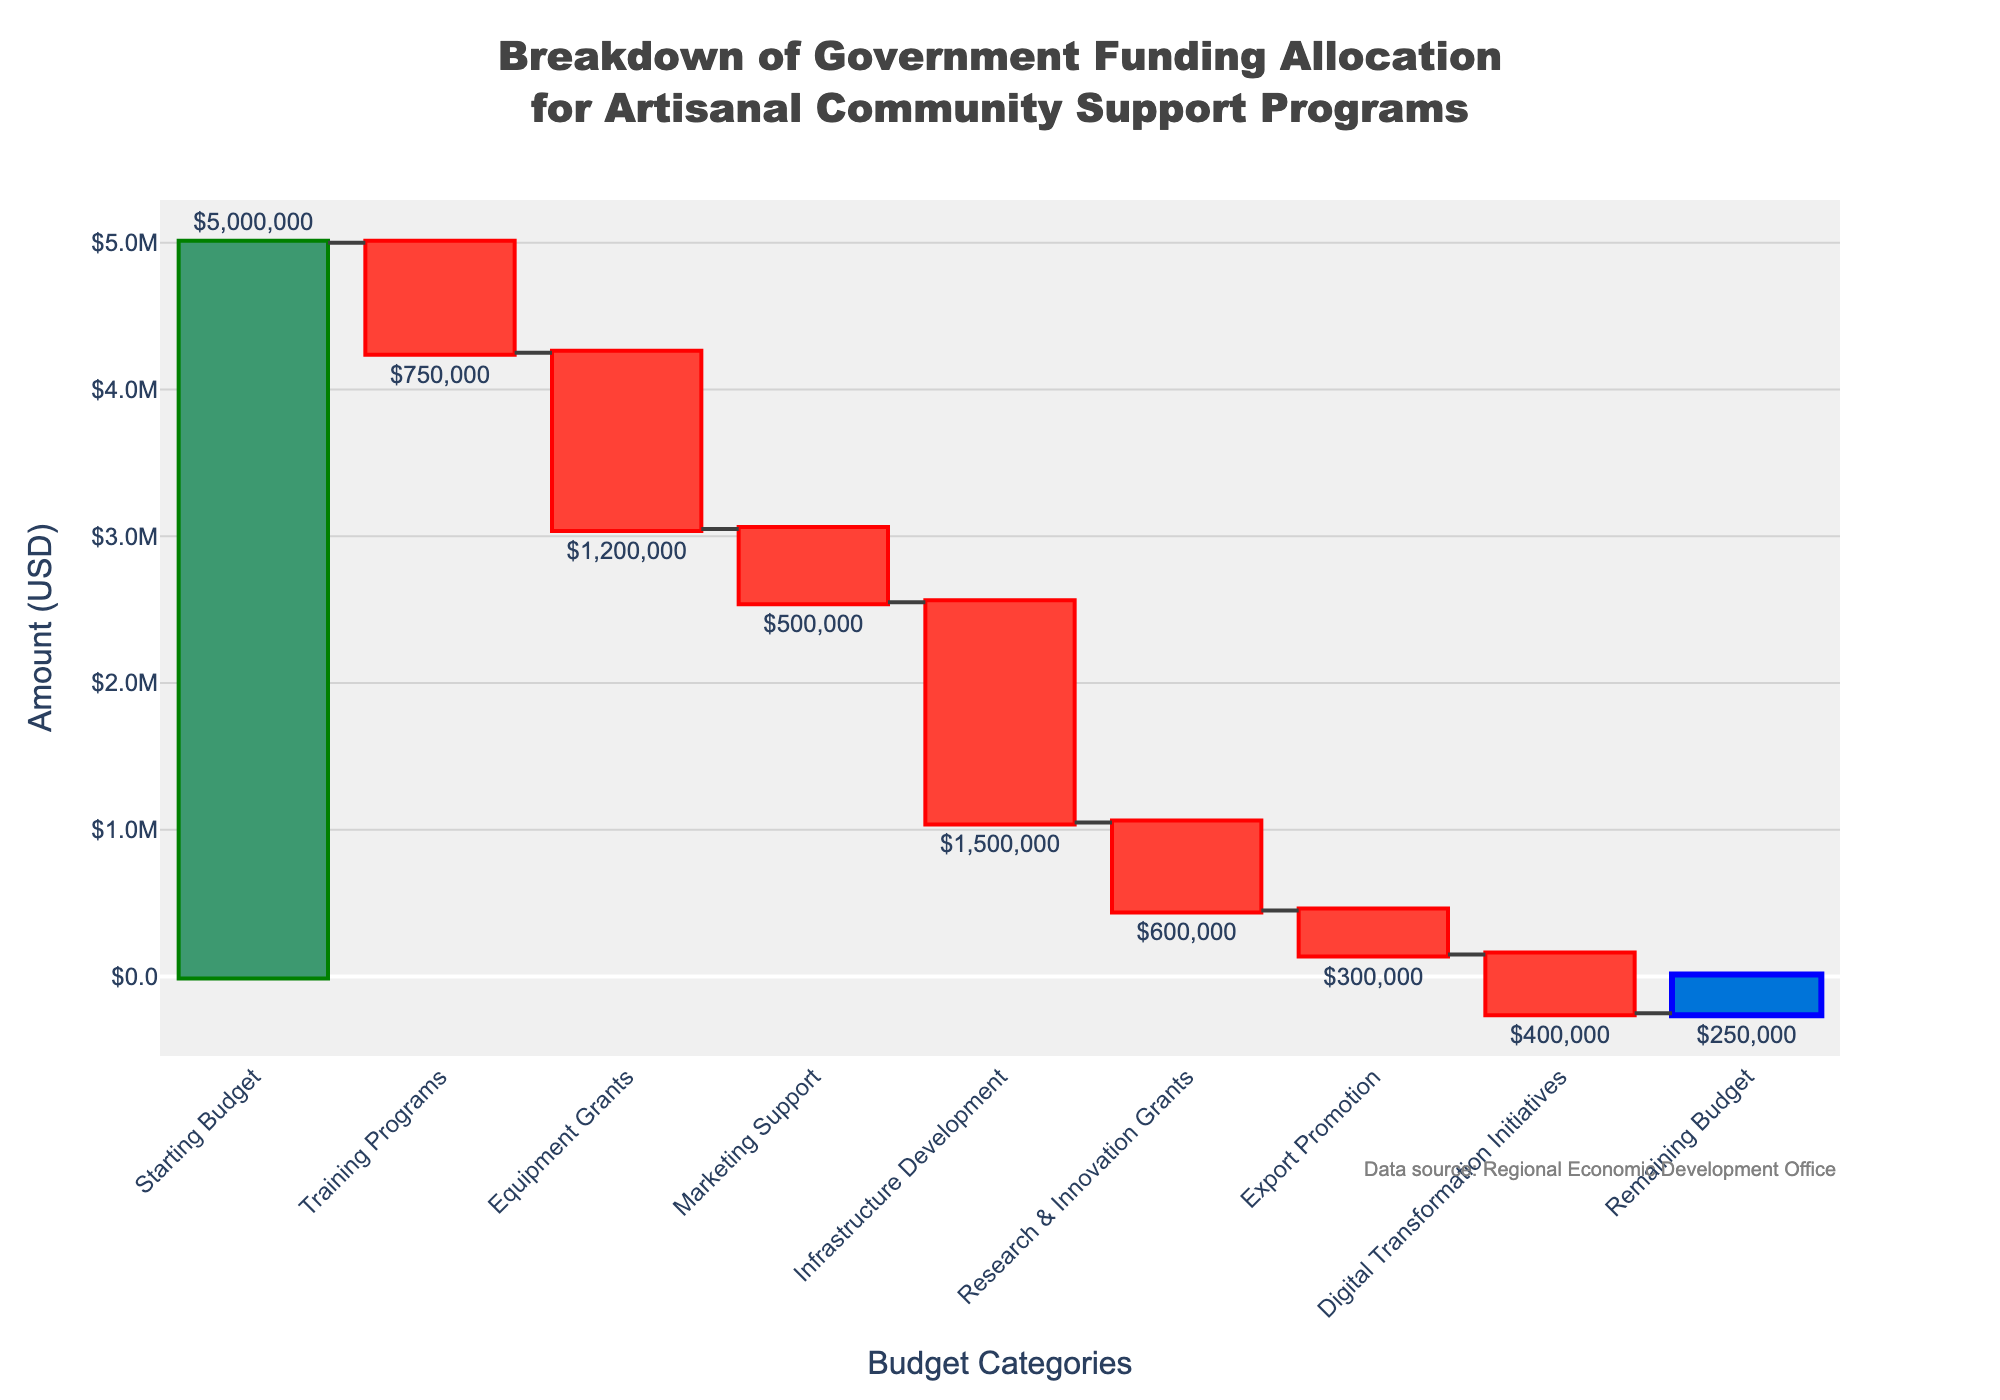What is the initial budget for the artisanal community support programs? The initial budget is shown as "Starting Budget" in the figure, with a value of $5,000,000.
Answer: $5,000,000 What is the remaining budget after all allocations? The remaining budget is shown as "Remaining Budget" in the figure, with a value of $250,000.
Answer: $250,000 How much funding is allocated to Training Programs? The funding allocated to Training Programs is indicated by a downward bar labeled "Training Programs" with a value of $750,000.
Answer: $750,000 Which category received the largest allocation of funds? By observing the lengths of the bars corresponding to negative values, "Infrastructure Development" received the largest allocation of $1,500,000.
Answer: Infrastructure Development How does the allocation for Digital Transformation Initiatives compare to that for Export Promotion? The figure shows a bar for Digital Transformation Initiatives with a value of $400,000 and a bar for Export Promotion with a value of $300,000. Digital Transformation Initiatives received $100,000 more.
Answer: Digital Transformation Initiatives received $100,000 more What was the total amount allocated to Training Programs, Equipment Grants, and Marketing Support combined? Sum the values for Training Programs ($750,000), Equipment Grants ($1,200,000), and Marketing Support ($500,000). The total is $750,000 + $1,200,000 + $500,000 = $2,450,000.
Answer: $2,450,000 What percentage of the total initial budget was allocated to Infrastructure Development? The allocation for Infrastructure Development is $1,500,000, and the initial budget is $5,000,000. The percentage is ($1,500,000 / $5,000,000) * 100%.
Answer: 30% How many categories resulted in budget decreases? The categories that caused budget decreases are those with negative values: Training Programs, Equipment Grants, Marketing Support, Infrastructure Development, Research & Innovation Grants, Export Promotion, and Digital Transformation Initiatives. There are 7 of them.
Answer: 7 Which category has the smallest allocation, and what is its value? By comparing the bar lengths and values, the smallest allocation goes to Export Promotion with a value of $300,000.
Answer: Export Promotion, $300,000 What is the total allocation for all categories combined (excluding the starting and remaining budgets)? Sum the absolute values of all categories except "Starting Budget" and "Remaining Budget": $750,000 (Training Programs) + $1,200,000 (Equipment Grants) + $500,000 (Marketing Support) + $1,500,000 (Infrastructure Development) + $600,000 (Research & Innovation Grants) + $300,000 (Export Promotion) + $400,000 (Digital Transformation Initiatives) = $5,250,000.
Answer: $5,250,000 